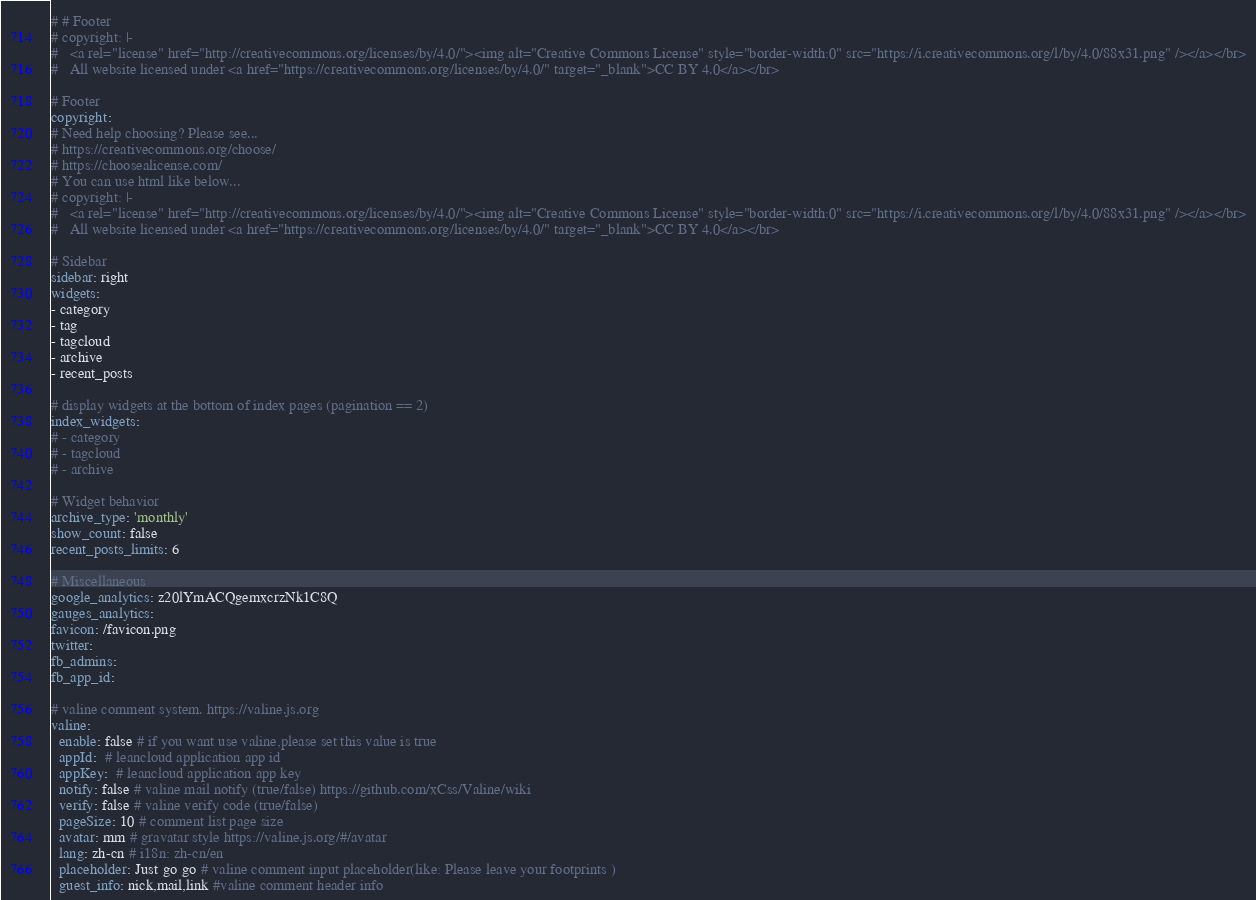Convert code to text. <code><loc_0><loc_0><loc_500><loc_500><_YAML_>
# # Footer
# copyright: |-
#   <a rel="license" href="http://creativecommons.org/licenses/by/4.0/"><img alt="Creative Commons License" style="border-width:0" src="https://i.creativecommons.org/l/by/4.0/88x31.png" /></a></br>
#   All website licensed under <a href="https://creativecommons.org/licenses/by/4.0/" target="_blank">CC BY 4.0</a></br>

# Footer
copyright:
# Need help choosing? Please see...
# https://creativecommons.org/choose/
# https://choosealicense.com/
# You can use html like below...
# copyright: |-
#   <a rel="license" href="http://creativecommons.org/licenses/by/4.0/"><img alt="Creative Commons License" style="border-width:0" src="https://i.creativecommons.org/l/by/4.0/88x31.png" /></a></br>
#   All website licensed under <a href="https://creativecommons.org/licenses/by/4.0/" target="_blank">CC BY 4.0</a></br>

# Sidebar
sidebar: right
widgets:
- category
- tag
- tagcloud
- archive
- recent_posts

# display widgets at the bottom of index pages (pagination == 2)
index_widgets:
# - category
# - tagcloud
# - archive

# Widget behavior
archive_type: 'monthly'
show_count: false
recent_posts_limits: 6

# Miscellaneous
google_analytics: z20lYmACQgemxcrzNk1C8Q
gauges_analytics:
favicon: /favicon.png
twitter:
fb_admins:
fb_app_id:

# valine comment system. https://valine.js.org
valine:
  enable: false # if you want use valine,please set this value is true
  appId:  # leancloud application app id
  appKey:  # leancloud application app key
  notify: false # valine mail notify (true/false) https://github.com/xCss/Valine/wiki
  verify: false # valine verify code (true/false)
  pageSize: 10 # comment list page size
  avatar: mm # gravatar style https://valine.js.org/#/avatar
  lang: zh-cn # i18n: zh-cn/en
  placeholder: Just go go # valine comment input placeholder(like: Please leave your footprints )
  guest_info: nick,mail,link #valine comment header info
</code> 